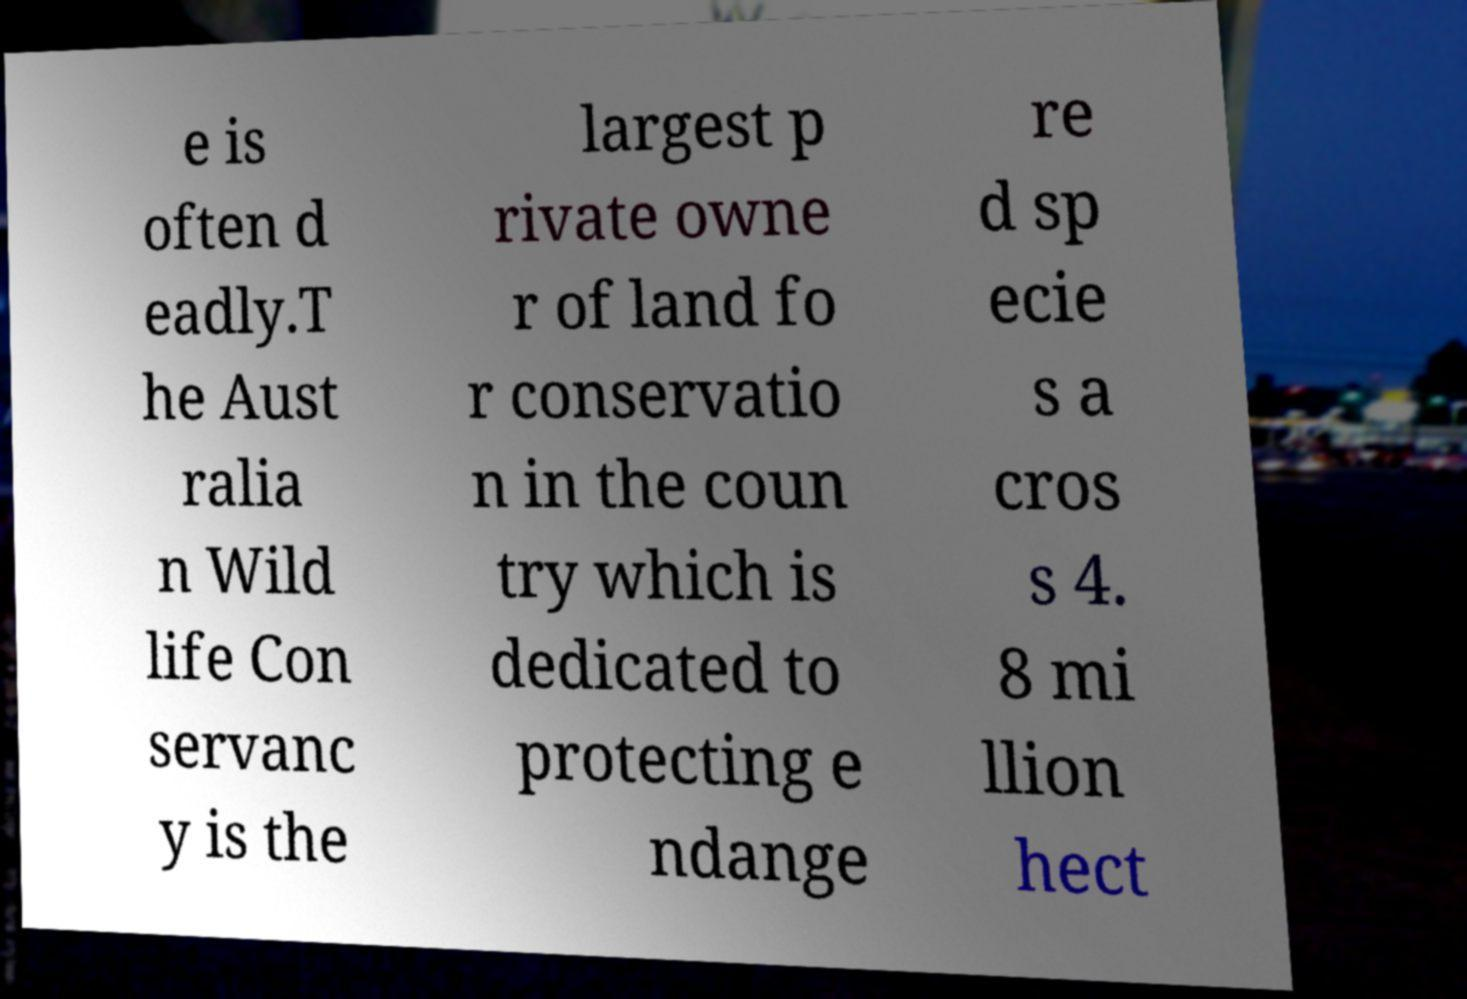What messages or text are displayed in this image? I need them in a readable, typed format. e is often d eadly.T he Aust ralia n Wild life Con servanc y is the largest p rivate owne r of land fo r conservatio n in the coun try which is dedicated to protecting e ndange re d sp ecie s a cros s 4. 8 mi llion hect 